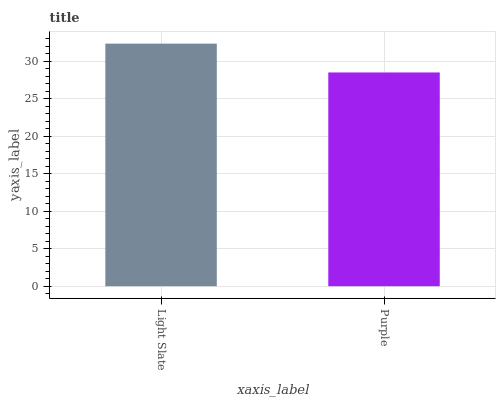Is Purple the minimum?
Answer yes or no. Yes. Is Light Slate the maximum?
Answer yes or no. Yes. Is Purple the maximum?
Answer yes or no. No. Is Light Slate greater than Purple?
Answer yes or no. Yes. Is Purple less than Light Slate?
Answer yes or no. Yes. Is Purple greater than Light Slate?
Answer yes or no. No. Is Light Slate less than Purple?
Answer yes or no. No. Is Light Slate the high median?
Answer yes or no. Yes. Is Purple the low median?
Answer yes or no. Yes. Is Purple the high median?
Answer yes or no. No. Is Light Slate the low median?
Answer yes or no. No. 